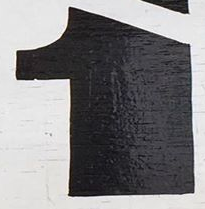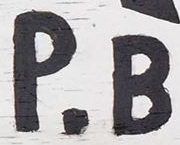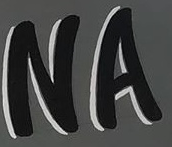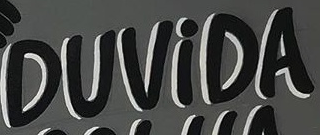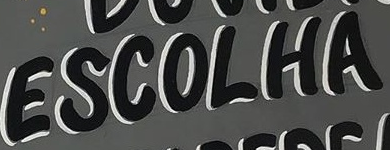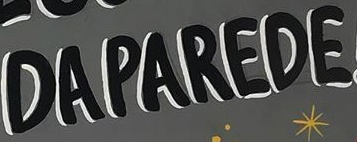What text is displayed in these images sequentially, separated by a semicolon? 1; P.B; NA; DUViDA; ESCOLHA; DAPAREDE 